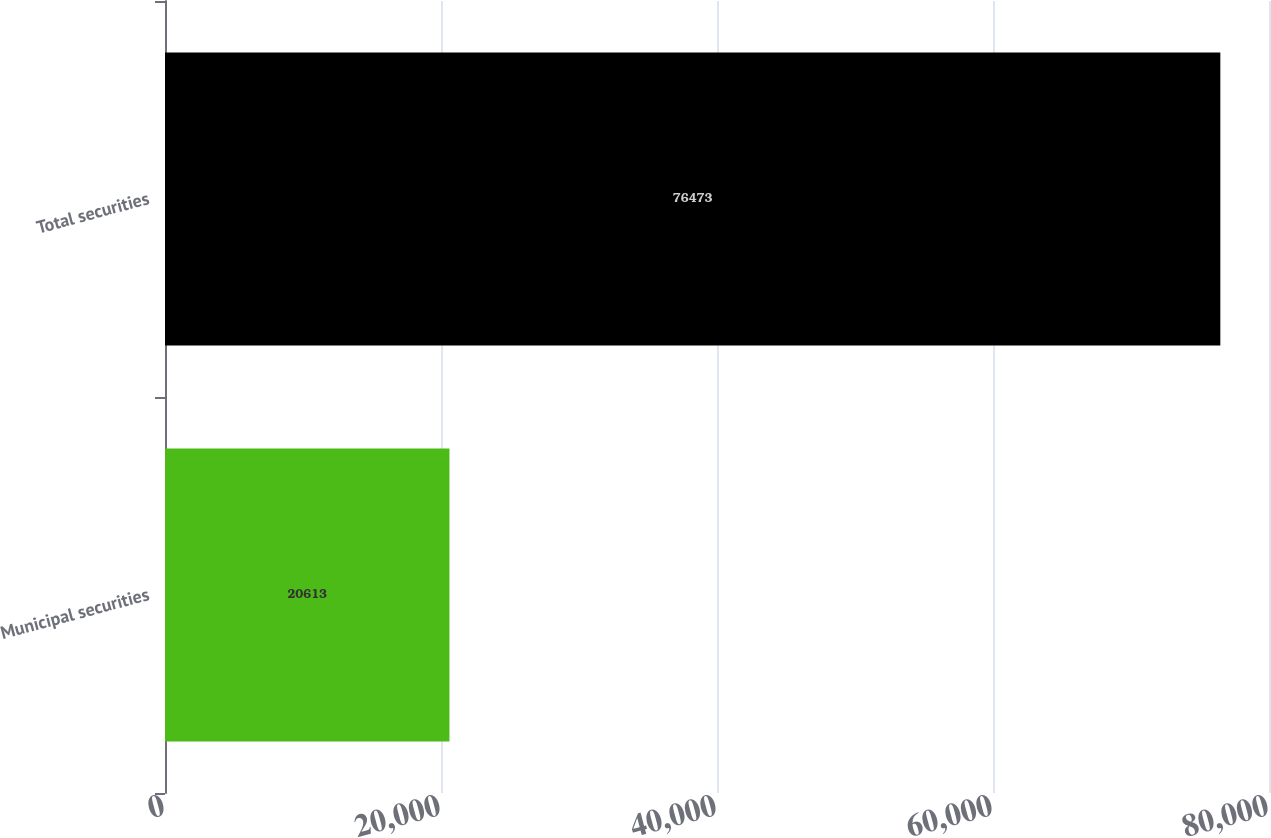Convert chart to OTSL. <chart><loc_0><loc_0><loc_500><loc_500><bar_chart><fcel>Municipal securities<fcel>Total securities<nl><fcel>20613<fcel>76473<nl></chart> 